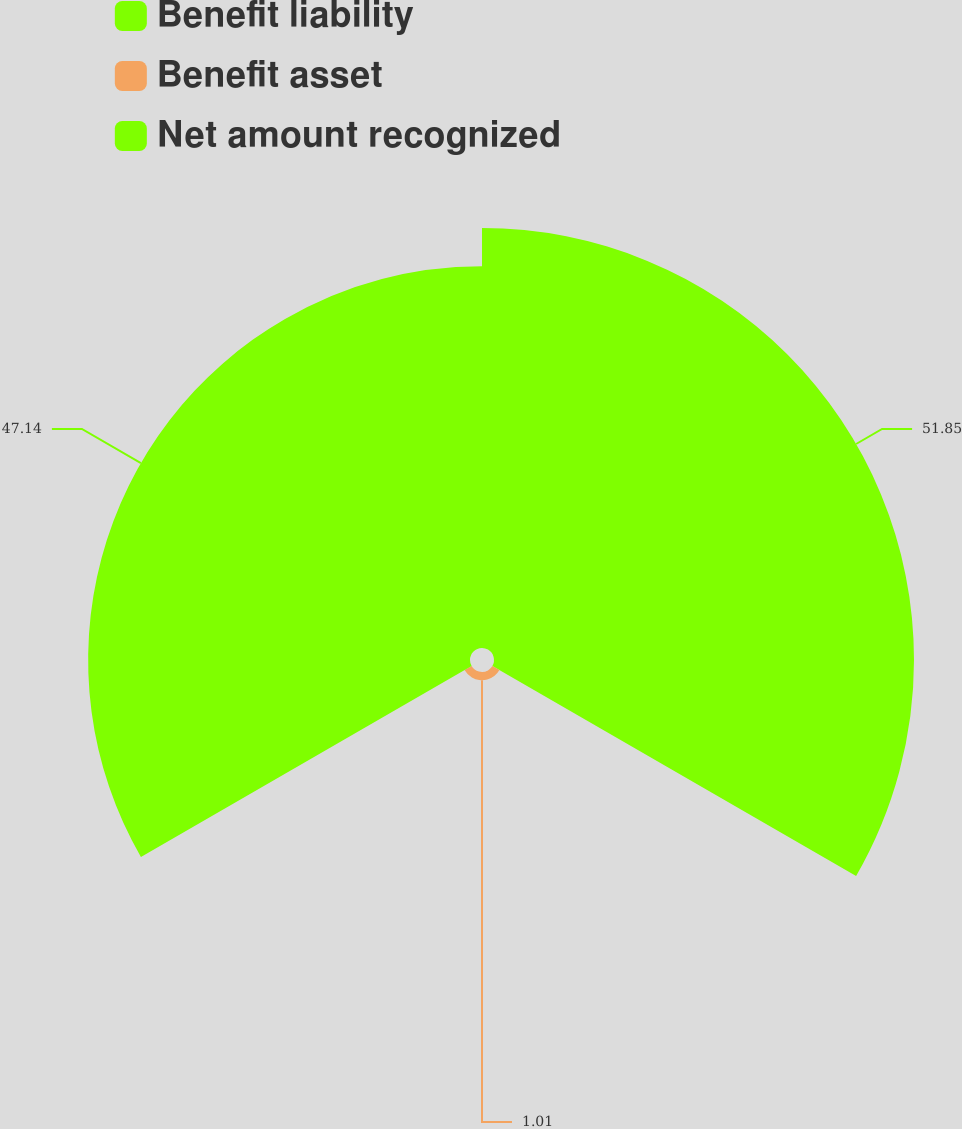<chart> <loc_0><loc_0><loc_500><loc_500><pie_chart><fcel>Benefit liability<fcel>Benefit asset<fcel>Net amount recognized<nl><fcel>51.85%<fcel>1.01%<fcel>47.14%<nl></chart> 